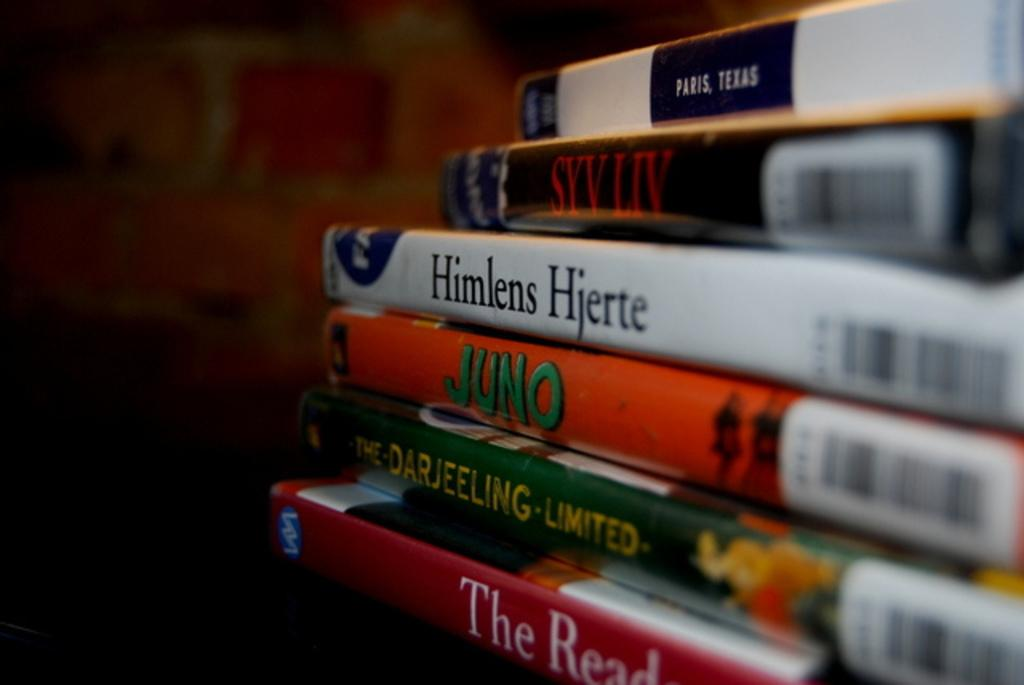<image>
Share a concise interpretation of the image provided. DVD cases are stacked on one another, including the movie Juno. 